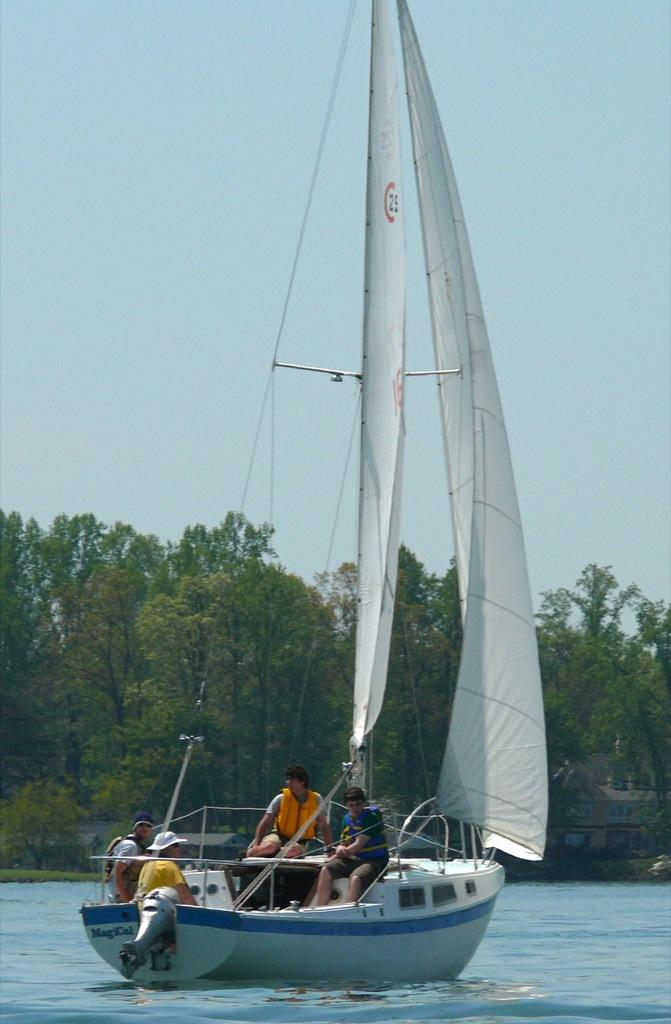Where was the image taken? The image was clicked outside. What can be seen at the bottom of the image? There is water at the bottom of the image. What is in the water? There is a boat in the water. Who is in the boat? There are people in the boat. What is in the middle of the image? There are trees in the middle of the image. What is visible at the top of the image? The sky is visible at the top of the image. What type of box is being used to store the town in the image? There is no box or town present in the image; it features a boat with people on water, surrounded by trees and sky. 